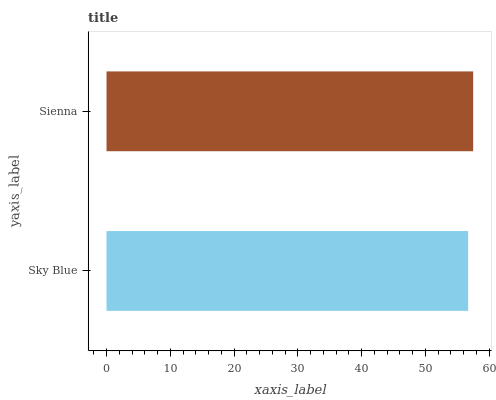Is Sky Blue the minimum?
Answer yes or no. Yes. Is Sienna the maximum?
Answer yes or no. Yes. Is Sienna the minimum?
Answer yes or no. No. Is Sienna greater than Sky Blue?
Answer yes or no. Yes. Is Sky Blue less than Sienna?
Answer yes or no. Yes. Is Sky Blue greater than Sienna?
Answer yes or no. No. Is Sienna less than Sky Blue?
Answer yes or no. No. Is Sienna the high median?
Answer yes or no. Yes. Is Sky Blue the low median?
Answer yes or no. Yes. Is Sky Blue the high median?
Answer yes or no. No. Is Sienna the low median?
Answer yes or no. No. 